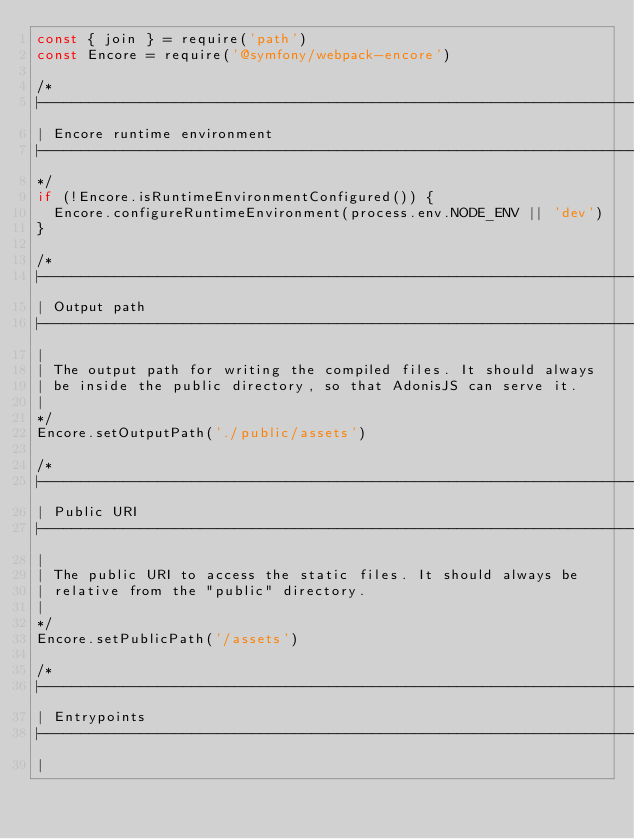Convert code to text. <code><loc_0><loc_0><loc_500><loc_500><_JavaScript_>const { join } = require('path')
const Encore = require('@symfony/webpack-encore')

/*
|--------------------------------------------------------------------------
| Encore runtime environment
|--------------------------------------------------------------------------
*/
if (!Encore.isRuntimeEnvironmentConfigured()) {
  Encore.configureRuntimeEnvironment(process.env.NODE_ENV || 'dev')
}

/*
|--------------------------------------------------------------------------
| Output path
|--------------------------------------------------------------------------
|
| The output path for writing the compiled files. It should always
| be inside the public directory, so that AdonisJS can serve it.
|
*/
Encore.setOutputPath('./public/assets')

/*
|--------------------------------------------------------------------------
| Public URI
|--------------------------------------------------------------------------
|
| The public URI to access the static files. It should always be
| relative from the "public" directory.
|
*/
Encore.setPublicPath('/assets')

/*
|--------------------------------------------------------------------------
| Entrypoints
|--------------------------------------------------------------------------
|</code> 